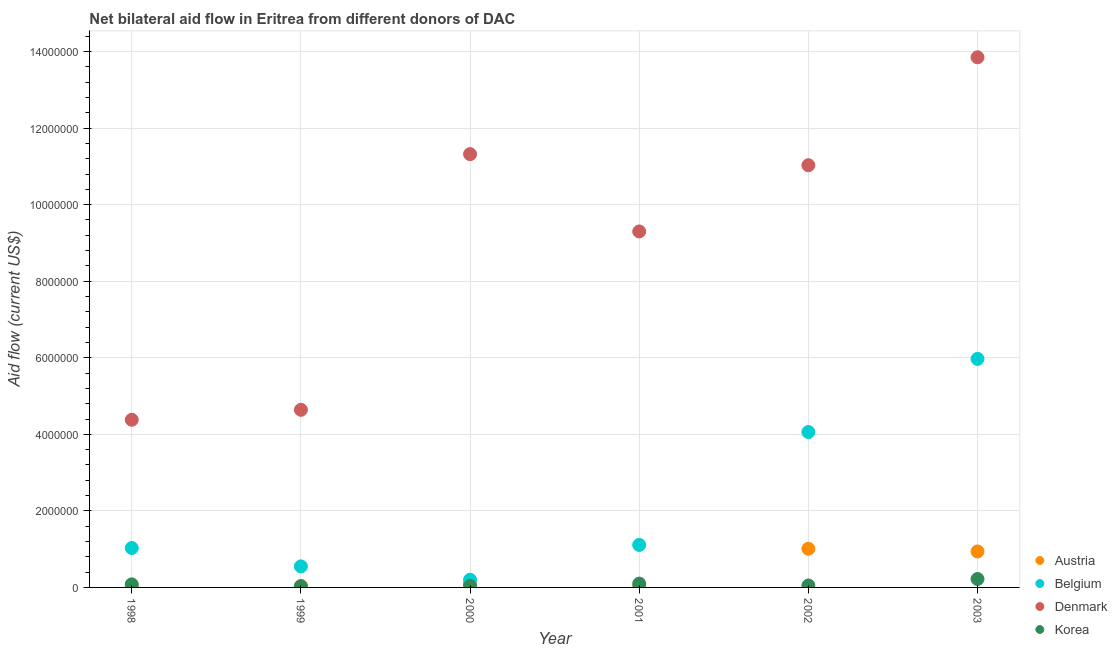What is the amount of aid given by korea in 1998?
Keep it short and to the point. 8.00e+04. Across all years, what is the maximum amount of aid given by denmark?
Ensure brevity in your answer.  1.38e+07. Across all years, what is the minimum amount of aid given by austria?
Ensure brevity in your answer.  2.00e+04. In which year was the amount of aid given by denmark maximum?
Keep it short and to the point. 2003. What is the total amount of aid given by denmark in the graph?
Keep it short and to the point. 5.45e+07. What is the difference between the amount of aid given by korea in 2002 and that in 2003?
Offer a very short reply. -1.70e+05. What is the difference between the amount of aid given by denmark in 2001 and the amount of aid given by austria in 2000?
Ensure brevity in your answer.  9.21e+06. What is the average amount of aid given by denmark per year?
Provide a succinct answer. 9.09e+06. In the year 2001, what is the difference between the amount of aid given by denmark and amount of aid given by austria?
Your answer should be compact. 9.28e+06. In how many years, is the amount of aid given by belgium greater than 2400000 US$?
Your answer should be very brief. 2. What is the ratio of the amount of aid given by denmark in 1999 to that in 2000?
Provide a succinct answer. 0.41. Is the difference between the amount of aid given by austria in 2001 and 2003 greater than the difference between the amount of aid given by denmark in 2001 and 2003?
Ensure brevity in your answer.  Yes. What is the difference between the highest and the second highest amount of aid given by belgium?
Keep it short and to the point. 1.91e+06. What is the difference between the highest and the lowest amount of aid given by austria?
Provide a succinct answer. 9.90e+05. Is the sum of the amount of aid given by austria in 2000 and 2003 greater than the maximum amount of aid given by korea across all years?
Offer a terse response. Yes. Is it the case that in every year, the sum of the amount of aid given by austria and amount of aid given by belgium is greater than the amount of aid given by denmark?
Your answer should be very brief. No. Is the amount of aid given by korea strictly greater than the amount of aid given by belgium over the years?
Give a very brief answer. No. Is the amount of aid given by korea strictly less than the amount of aid given by denmark over the years?
Offer a very short reply. Yes. How many years are there in the graph?
Your response must be concise. 6. What is the difference between two consecutive major ticks on the Y-axis?
Provide a succinct answer. 2.00e+06. Does the graph contain any zero values?
Provide a succinct answer. No. What is the title of the graph?
Your answer should be very brief. Net bilateral aid flow in Eritrea from different donors of DAC. Does "France" appear as one of the legend labels in the graph?
Your response must be concise. No. What is the Aid flow (current US$) of Belgium in 1998?
Give a very brief answer. 1.03e+06. What is the Aid flow (current US$) in Denmark in 1998?
Provide a short and direct response. 4.38e+06. What is the Aid flow (current US$) of Korea in 1998?
Ensure brevity in your answer.  8.00e+04. What is the Aid flow (current US$) of Austria in 1999?
Provide a succinct answer. 4.00e+04. What is the Aid flow (current US$) in Belgium in 1999?
Give a very brief answer. 5.50e+05. What is the Aid flow (current US$) in Denmark in 1999?
Your answer should be compact. 4.64e+06. What is the Aid flow (current US$) in Korea in 1999?
Give a very brief answer. 3.00e+04. What is the Aid flow (current US$) of Austria in 2000?
Ensure brevity in your answer.  9.00e+04. What is the Aid flow (current US$) in Denmark in 2000?
Your answer should be compact. 1.13e+07. What is the Aid flow (current US$) of Belgium in 2001?
Provide a short and direct response. 1.11e+06. What is the Aid flow (current US$) of Denmark in 2001?
Your answer should be very brief. 9.30e+06. What is the Aid flow (current US$) of Austria in 2002?
Provide a succinct answer. 1.01e+06. What is the Aid flow (current US$) in Belgium in 2002?
Offer a terse response. 4.06e+06. What is the Aid flow (current US$) of Denmark in 2002?
Keep it short and to the point. 1.10e+07. What is the Aid flow (current US$) in Korea in 2002?
Give a very brief answer. 5.00e+04. What is the Aid flow (current US$) of Austria in 2003?
Provide a short and direct response. 9.40e+05. What is the Aid flow (current US$) in Belgium in 2003?
Your answer should be very brief. 5.97e+06. What is the Aid flow (current US$) in Denmark in 2003?
Offer a very short reply. 1.38e+07. Across all years, what is the maximum Aid flow (current US$) of Austria?
Offer a very short reply. 1.01e+06. Across all years, what is the maximum Aid flow (current US$) in Belgium?
Ensure brevity in your answer.  5.97e+06. Across all years, what is the maximum Aid flow (current US$) in Denmark?
Provide a succinct answer. 1.38e+07. Across all years, what is the maximum Aid flow (current US$) of Korea?
Your response must be concise. 2.20e+05. Across all years, what is the minimum Aid flow (current US$) of Denmark?
Give a very brief answer. 4.38e+06. What is the total Aid flow (current US$) in Austria in the graph?
Offer a very short reply. 2.12e+06. What is the total Aid flow (current US$) in Belgium in the graph?
Provide a short and direct response. 1.29e+07. What is the total Aid flow (current US$) in Denmark in the graph?
Make the answer very short. 5.45e+07. What is the total Aid flow (current US$) in Korea in the graph?
Your answer should be very brief. 5.20e+05. What is the difference between the Aid flow (current US$) in Austria in 1998 and that in 1999?
Your answer should be very brief. -2.00e+04. What is the difference between the Aid flow (current US$) in Belgium in 1998 and that in 1999?
Provide a short and direct response. 4.80e+05. What is the difference between the Aid flow (current US$) in Korea in 1998 and that in 1999?
Provide a short and direct response. 5.00e+04. What is the difference between the Aid flow (current US$) of Belgium in 1998 and that in 2000?
Provide a succinct answer. 8.30e+05. What is the difference between the Aid flow (current US$) of Denmark in 1998 and that in 2000?
Offer a very short reply. -6.94e+06. What is the difference between the Aid flow (current US$) in Belgium in 1998 and that in 2001?
Your response must be concise. -8.00e+04. What is the difference between the Aid flow (current US$) in Denmark in 1998 and that in 2001?
Give a very brief answer. -4.92e+06. What is the difference between the Aid flow (current US$) in Austria in 1998 and that in 2002?
Provide a short and direct response. -9.90e+05. What is the difference between the Aid flow (current US$) in Belgium in 1998 and that in 2002?
Give a very brief answer. -3.03e+06. What is the difference between the Aid flow (current US$) of Denmark in 1998 and that in 2002?
Your answer should be very brief. -6.65e+06. What is the difference between the Aid flow (current US$) in Austria in 1998 and that in 2003?
Your answer should be very brief. -9.20e+05. What is the difference between the Aid flow (current US$) in Belgium in 1998 and that in 2003?
Your answer should be compact. -4.94e+06. What is the difference between the Aid flow (current US$) in Denmark in 1998 and that in 2003?
Provide a short and direct response. -9.47e+06. What is the difference between the Aid flow (current US$) of Austria in 1999 and that in 2000?
Offer a very short reply. -5.00e+04. What is the difference between the Aid flow (current US$) in Denmark in 1999 and that in 2000?
Provide a succinct answer. -6.68e+06. What is the difference between the Aid flow (current US$) of Austria in 1999 and that in 2001?
Make the answer very short. 2.00e+04. What is the difference between the Aid flow (current US$) of Belgium in 1999 and that in 2001?
Offer a very short reply. -5.60e+05. What is the difference between the Aid flow (current US$) in Denmark in 1999 and that in 2001?
Provide a succinct answer. -4.66e+06. What is the difference between the Aid flow (current US$) in Korea in 1999 and that in 2001?
Provide a succinct answer. -7.00e+04. What is the difference between the Aid flow (current US$) in Austria in 1999 and that in 2002?
Provide a succinct answer. -9.70e+05. What is the difference between the Aid flow (current US$) in Belgium in 1999 and that in 2002?
Keep it short and to the point. -3.51e+06. What is the difference between the Aid flow (current US$) in Denmark in 1999 and that in 2002?
Offer a very short reply. -6.39e+06. What is the difference between the Aid flow (current US$) in Austria in 1999 and that in 2003?
Give a very brief answer. -9.00e+05. What is the difference between the Aid flow (current US$) of Belgium in 1999 and that in 2003?
Make the answer very short. -5.42e+06. What is the difference between the Aid flow (current US$) of Denmark in 1999 and that in 2003?
Your response must be concise. -9.21e+06. What is the difference between the Aid flow (current US$) of Korea in 1999 and that in 2003?
Give a very brief answer. -1.90e+05. What is the difference between the Aid flow (current US$) of Austria in 2000 and that in 2001?
Offer a very short reply. 7.00e+04. What is the difference between the Aid flow (current US$) in Belgium in 2000 and that in 2001?
Your response must be concise. -9.10e+05. What is the difference between the Aid flow (current US$) in Denmark in 2000 and that in 2001?
Your answer should be compact. 2.02e+06. What is the difference between the Aid flow (current US$) in Austria in 2000 and that in 2002?
Make the answer very short. -9.20e+05. What is the difference between the Aid flow (current US$) of Belgium in 2000 and that in 2002?
Your answer should be compact. -3.86e+06. What is the difference between the Aid flow (current US$) of Denmark in 2000 and that in 2002?
Provide a short and direct response. 2.90e+05. What is the difference between the Aid flow (current US$) of Austria in 2000 and that in 2003?
Make the answer very short. -8.50e+05. What is the difference between the Aid flow (current US$) in Belgium in 2000 and that in 2003?
Your response must be concise. -5.77e+06. What is the difference between the Aid flow (current US$) in Denmark in 2000 and that in 2003?
Ensure brevity in your answer.  -2.53e+06. What is the difference between the Aid flow (current US$) in Korea in 2000 and that in 2003?
Provide a short and direct response. -1.80e+05. What is the difference between the Aid flow (current US$) of Austria in 2001 and that in 2002?
Give a very brief answer. -9.90e+05. What is the difference between the Aid flow (current US$) in Belgium in 2001 and that in 2002?
Ensure brevity in your answer.  -2.95e+06. What is the difference between the Aid flow (current US$) of Denmark in 2001 and that in 2002?
Give a very brief answer. -1.73e+06. What is the difference between the Aid flow (current US$) of Austria in 2001 and that in 2003?
Offer a terse response. -9.20e+05. What is the difference between the Aid flow (current US$) in Belgium in 2001 and that in 2003?
Your answer should be compact. -4.86e+06. What is the difference between the Aid flow (current US$) of Denmark in 2001 and that in 2003?
Provide a short and direct response. -4.55e+06. What is the difference between the Aid flow (current US$) of Korea in 2001 and that in 2003?
Make the answer very short. -1.20e+05. What is the difference between the Aid flow (current US$) of Austria in 2002 and that in 2003?
Give a very brief answer. 7.00e+04. What is the difference between the Aid flow (current US$) of Belgium in 2002 and that in 2003?
Offer a very short reply. -1.91e+06. What is the difference between the Aid flow (current US$) in Denmark in 2002 and that in 2003?
Make the answer very short. -2.82e+06. What is the difference between the Aid flow (current US$) of Austria in 1998 and the Aid flow (current US$) of Belgium in 1999?
Give a very brief answer. -5.30e+05. What is the difference between the Aid flow (current US$) of Austria in 1998 and the Aid flow (current US$) of Denmark in 1999?
Give a very brief answer. -4.62e+06. What is the difference between the Aid flow (current US$) of Austria in 1998 and the Aid flow (current US$) of Korea in 1999?
Give a very brief answer. -10000. What is the difference between the Aid flow (current US$) in Belgium in 1998 and the Aid flow (current US$) in Denmark in 1999?
Make the answer very short. -3.61e+06. What is the difference between the Aid flow (current US$) in Denmark in 1998 and the Aid flow (current US$) in Korea in 1999?
Offer a very short reply. 4.35e+06. What is the difference between the Aid flow (current US$) in Austria in 1998 and the Aid flow (current US$) in Belgium in 2000?
Provide a succinct answer. -1.80e+05. What is the difference between the Aid flow (current US$) in Austria in 1998 and the Aid flow (current US$) in Denmark in 2000?
Offer a terse response. -1.13e+07. What is the difference between the Aid flow (current US$) in Belgium in 1998 and the Aid flow (current US$) in Denmark in 2000?
Ensure brevity in your answer.  -1.03e+07. What is the difference between the Aid flow (current US$) in Belgium in 1998 and the Aid flow (current US$) in Korea in 2000?
Your answer should be compact. 9.90e+05. What is the difference between the Aid flow (current US$) of Denmark in 1998 and the Aid flow (current US$) of Korea in 2000?
Ensure brevity in your answer.  4.34e+06. What is the difference between the Aid flow (current US$) of Austria in 1998 and the Aid flow (current US$) of Belgium in 2001?
Make the answer very short. -1.09e+06. What is the difference between the Aid flow (current US$) in Austria in 1998 and the Aid flow (current US$) in Denmark in 2001?
Give a very brief answer. -9.28e+06. What is the difference between the Aid flow (current US$) of Austria in 1998 and the Aid flow (current US$) of Korea in 2001?
Provide a short and direct response. -8.00e+04. What is the difference between the Aid flow (current US$) in Belgium in 1998 and the Aid flow (current US$) in Denmark in 2001?
Keep it short and to the point. -8.27e+06. What is the difference between the Aid flow (current US$) in Belgium in 1998 and the Aid flow (current US$) in Korea in 2001?
Offer a very short reply. 9.30e+05. What is the difference between the Aid flow (current US$) of Denmark in 1998 and the Aid flow (current US$) of Korea in 2001?
Your answer should be compact. 4.28e+06. What is the difference between the Aid flow (current US$) in Austria in 1998 and the Aid flow (current US$) in Belgium in 2002?
Offer a very short reply. -4.04e+06. What is the difference between the Aid flow (current US$) of Austria in 1998 and the Aid flow (current US$) of Denmark in 2002?
Provide a short and direct response. -1.10e+07. What is the difference between the Aid flow (current US$) in Belgium in 1998 and the Aid flow (current US$) in Denmark in 2002?
Your answer should be very brief. -1.00e+07. What is the difference between the Aid flow (current US$) in Belgium in 1998 and the Aid flow (current US$) in Korea in 2002?
Offer a terse response. 9.80e+05. What is the difference between the Aid flow (current US$) of Denmark in 1998 and the Aid flow (current US$) of Korea in 2002?
Ensure brevity in your answer.  4.33e+06. What is the difference between the Aid flow (current US$) in Austria in 1998 and the Aid flow (current US$) in Belgium in 2003?
Your answer should be compact. -5.95e+06. What is the difference between the Aid flow (current US$) of Austria in 1998 and the Aid flow (current US$) of Denmark in 2003?
Provide a short and direct response. -1.38e+07. What is the difference between the Aid flow (current US$) in Belgium in 1998 and the Aid flow (current US$) in Denmark in 2003?
Your answer should be compact. -1.28e+07. What is the difference between the Aid flow (current US$) of Belgium in 1998 and the Aid flow (current US$) of Korea in 2003?
Keep it short and to the point. 8.10e+05. What is the difference between the Aid flow (current US$) in Denmark in 1998 and the Aid flow (current US$) in Korea in 2003?
Give a very brief answer. 4.16e+06. What is the difference between the Aid flow (current US$) of Austria in 1999 and the Aid flow (current US$) of Denmark in 2000?
Offer a very short reply. -1.13e+07. What is the difference between the Aid flow (current US$) in Belgium in 1999 and the Aid flow (current US$) in Denmark in 2000?
Keep it short and to the point. -1.08e+07. What is the difference between the Aid flow (current US$) of Belgium in 1999 and the Aid flow (current US$) of Korea in 2000?
Your answer should be compact. 5.10e+05. What is the difference between the Aid flow (current US$) in Denmark in 1999 and the Aid flow (current US$) in Korea in 2000?
Offer a terse response. 4.60e+06. What is the difference between the Aid flow (current US$) of Austria in 1999 and the Aid flow (current US$) of Belgium in 2001?
Keep it short and to the point. -1.07e+06. What is the difference between the Aid flow (current US$) of Austria in 1999 and the Aid flow (current US$) of Denmark in 2001?
Offer a very short reply. -9.26e+06. What is the difference between the Aid flow (current US$) in Belgium in 1999 and the Aid flow (current US$) in Denmark in 2001?
Give a very brief answer. -8.75e+06. What is the difference between the Aid flow (current US$) of Belgium in 1999 and the Aid flow (current US$) of Korea in 2001?
Your answer should be compact. 4.50e+05. What is the difference between the Aid flow (current US$) of Denmark in 1999 and the Aid flow (current US$) of Korea in 2001?
Your response must be concise. 4.54e+06. What is the difference between the Aid flow (current US$) in Austria in 1999 and the Aid flow (current US$) in Belgium in 2002?
Your answer should be compact. -4.02e+06. What is the difference between the Aid flow (current US$) of Austria in 1999 and the Aid flow (current US$) of Denmark in 2002?
Ensure brevity in your answer.  -1.10e+07. What is the difference between the Aid flow (current US$) of Belgium in 1999 and the Aid flow (current US$) of Denmark in 2002?
Your answer should be compact. -1.05e+07. What is the difference between the Aid flow (current US$) of Belgium in 1999 and the Aid flow (current US$) of Korea in 2002?
Your answer should be compact. 5.00e+05. What is the difference between the Aid flow (current US$) in Denmark in 1999 and the Aid flow (current US$) in Korea in 2002?
Offer a very short reply. 4.59e+06. What is the difference between the Aid flow (current US$) of Austria in 1999 and the Aid flow (current US$) of Belgium in 2003?
Ensure brevity in your answer.  -5.93e+06. What is the difference between the Aid flow (current US$) in Austria in 1999 and the Aid flow (current US$) in Denmark in 2003?
Your answer should be very brief. -1.38e+07. What is the difference between the Aid flow (current US$) in Austria in 1999 and the Aid flow (current US$) in Korea in 2003?
Keep it short and to the point. -1.80e+05. What is the difference between the Aid flow (current US$) of Belgium in 1999 and the Aid flow (current US$) of Denmark in 2003?
Your answer should be compact. -1.33e+07. What is the difference between the Aid flow (current US$) of Belgium in 1999 and the Aid flow (current US$) of Korea in 2003?
Keep it short and to the point. 3.30e+05. What is the difference between the Aid flow (current US$) in Denmark in 1999 and the Aid flow (current US$) in Korea in 2003?
Keep it short and to the point. 4.42e+06. What is the difference between the Aid flow (current US$) in Austria in 2000 and the Aid flow (current US$) in Belgium in 2001?
Make the answer very short. -1.02e+06. What is the difference between the Aid flow (current US$) of Austria in 2000 and the Aid flow (current US$) of Denmark in 2001?
Provide a short and direct response. -9.21e+06. What is the difference between the Aid flow (current US$) of Austria in 2000 and the Aid flow (current US$) of Korea in 2001?
Your answer should be compact. -10000. What is the difference between the Aid flow (current US$) of Belgium in 2000 and the Aid flow (current US$) of Denmark in 2001?
Your answer should be compact. -9.10e+06. What is the difference between the Aid flow (current US$) in Denmark in 2000 and the Aid flow (current US$) in Korea in 2001?
Give a very brief answer. 1.12e+07. What is the difference between the Aid flow (current US$) in Austria in 2000 and the Aid flow (current US$) in Belgium in 2002?
Keep it short and to the point. -3.97e+06. What is the difference between the Aid flow (current US$) in Austria in 2000 and the Aid flow (current US$) in Denmark in 2002?
Ensure brevity in your answer.  -1.09e+07. What is the difference between the Aid flow (current US$) of Austria in 2000 and the Aid flow (current US$) of Korea in 2002?
Provide a short and direct response. 4.00e+04. What is the difference between the Aid flow (current US$) of Belgium in 2000 and the Aid flow (current US$) of Denmark in 2002?
Offer a terse response. -1.08e+07. What is the difference between the Aid flow (current US$) in Belgium in 2000 and the Aid flow (current US$) in Korea in 2002?
Give a very brief answer. 1.50e+05. What is the difference between the Aid flow (current US$) in Denmark in 2000 and the Aid flow (current US$) in Korea in 2002?
Ensure brevity in your answer.  1.13e+07. What is the difference between the Aid flow (current US$) of Austria in 2000 and the Aid flow (current US$) of Belgium in 2003?
Your answer should be compact. -5.88e+06. What is the difference between the Aid flow (current US$) of Austria in 2000 and the Aid flow (current US$) of Denmark in 2003?
Provide a short and direct response. -1.38e+07. What is the difference between the Aid flow (current US$) of Belgium in 2000 and the Aid flow (current US$) of Denmark in 2003?
Ensure brevity in your answer.  -1.36e+07. What is the difference between the Aid flow (current US$) in Belgium in 2000 and the Aid flow (current US$) in Korea in 2003?
Offer a terse response. -2.00e+04. What is the difference between the Aid flow (current US$) in Denmark in 2000 and the Aid flow (current US$) in Korea in 2003?
Make the answer very short. 1.11e+07. What is the difference between the Aid flow (current US$) in Austria in 2001 and the Aid flow (current US$) in Belgium in 2002?
Provide a short and direct response. -4.04e+06. What is the difference between the Aid flow (current US$) of Austria in 2001 and the Aid flow (current US$) of Denmark in 2002?
Give a very brief answer. -1.10e+07. What is the difference between the Aid flow (current US$) in Austria in 2001 and the Aid flow (current US$) in Korea in 2002?
Your answer should be compact. -3.00e+04. What is the difference between the Aid flow (current US$) in Belgium in 2001 and the Aid flow (current US$) in Denmark in 2002?
Provide a short and direct response. -9.92e+06. What is the difference between the Aid flow (current US$) in Belgium in 2001 and the Aid flow (current US$) in Korea in 2002?
Offer a terse response. 1.06e+06. What is the difference between the Aid flow (current US$) in Denmark in 2001 and the Aid flow (current US$) in Korea in 2002?
Provide a short and direct response. 9.25e+06. What is the difference between the Aid flow (current US$) in Austria in 2001 and the Aid flow (current US$) in Belgium in 2003?
Ensure brevity in your answer.  -5.95e+06. What is the difference between the Aid flow (current US$) in Austria in 2001 and the Aid flow (current US$) in Denmark in 2003?
Make the answer very short. -1.38e+07. What is the difference between the Aid flow (current US$) of Belgium in 2001 and the Aid flow (current US$) of Denmark in 2003?
Your answer should be compact. -1.27e+07. What is the difference between the Aid flow (current US$) of Belgium in 2001 and the Aid flow (current US$) of Korea in 2003?
Ensure brevity in your answer.  8.90e+05. What is the difference between the Aid flow (current US$) of Denmark in 2001 and the Aid flow (current US$) of Korea in 2003?
Your answer should be very brief. 9.08e+06. What is the difference between the Aid flow (current US$) of Austria in 2002 and the Aid flow (current US$) of Belgium in 2003?
Your answer should be very brief. -4.96e+06. What is the difference between the Aid flow (current US$) in Austria in 2002 and the Aid flow (current US$) in Denmark in 2003?
Provide a short and direct response. -1.28e+07. What is the difference between the Aid flow (current US$) of Austria in 2002 and the Aid flow (current US$) of Korea in 2003?
Your answer should be very brief. 7.90e+05. What is the difference between the Aid flow (current US$) in Belgium in 2002 and the Aid flow (current US$) in Denmark in 2003?
Your response must be concise. -9.79e+06. What is the difference between the Aid flow (current US$) in Belgium in 2002 and the Aid flow (current US$) in Korea in 2003?
Give a very brief answer. 3.84e+06. What is the difference between the Aid flow (current US$) of Denmark in 2002 and the Aid flow (current US$) of Korea in 2003?
Offer a very short reply. 1.08e+07. What is the average Aid flow (current US$) of Austria per year?
Offer a very short reply. 3.53e+05. What is the average Aid flow (current US$) of Belgium per year?
Ensure brevity in your answer.  2.15e+06. What is the average Aid flow (current US$) in Denmark per year?
Make the answer very short. 9.09e+06. What is the average Aid flow (current US$) in Korea per year?
Your answer should be very brief. 8.67e+04. In the year 1998, what is the difference between the Aid flow (current US$) in Austria and Aid flow (current US$) in Belgium?
Your response must be concise. -1.01e+06. In the year 1998, what is the difference between the Aid flow (current US$) of Austria and Aid flow (current US$) of Denmark?
Provide a succinct answer. -4.36e+06. In the year 1998, what is the difference between the Aid flow (current US$) in Belgium and Aid flow (current US$) in Denmark?
Give a very brief answer. -3.35e+06. In the year 1998, what is the difference between the Aid flow (current US$) of Belgium and Aid flow (current US$) of Korea?
Give a very brief answer. 9.50e+05. In the year 1998, what is the difference between the Aid flow (current US$) of Denmark and Aid flow (current US$) of Korea?
Offer a very short reply. 4.30e+06. In the year 1999, what is the difference between the Aid flow (current US$) of Austria and Aid flow (current US$) of Belgium?
Make the answer very short. -5.10e+05. In the year 1999, what is the difference between the Aid flow (current US$) of Austria and Aid flow (current US$) of Denmark?
Provide a succinct answer. -4.60e+06. In the year 1999, what is the difference between the Aid flow (current US$) of Austria and Aid flow (current US$) of Korea?
Make the answer very short. 10000. In the year 1999, what is the difference between the Aid flow (current US$) in Belgium and Aid flow (current US$) in Denmark?
Ensure brevity in your answer.  -4.09e+06. In the year 1999, what is the difference between the Aid flow (current US$) of Belgium and Aid flow (current US$) of Korea?
Provide a short and direct response. 5.20e+05. In the year 1999, what is the difference between the Aid flow (current US$) in Denmark and Aid flow (current US$) in Korea?
Provide a short and direct response. 4.61e+06. In the year 2000, what is the difference between the Aid flow (current US$) in Austria and Aid flow (current US$) in Denmark?
Your answer should be compact. -1.12e+07. In the year 2000, what is the difference between the Aid flow (current US$) in Belgium and Aid flow (current US$) in Denmark?
Your response must be concise. -1.11e+07. In the year 2000, what is the difference between the Aid flow (current US$) in Belgium and Aid flow (current US$) in Korea?
Your answer should be compact. 1.60e+05. In the year 2000, what is the difference between the Aid flow (current US$) of Denmark and Aid flow (current US$) of Korea?
Your answer should be very brief. 1.13e+07. In the year 2001, what is the difference between the Aid flow (current US$) of Austria and Aid flow (current US$) of Belgium?
Your answer should be compact. -1.09e+06. In the year 2001, what is the difference between the Aid flow (current US$) of Austria and Aid flow (current US$) of Denmark?
Ensure brevity in your answer.  -9.28e+06. In the year 2001, what is the difference between the Aid flow (current US$) of Belgium and Aid flow (current US$) of Denmark?
Offer a terse response. -8.19e+06. In the year 2001, what is the difference between the Aid flow (current US$) of Belgium and Aid flow (current US$) of Korea?
Provide a succinct answer. 1.01e+06. In the year 2001, what is the difference between the Aid flow (current US$) in Denmark and Aid flow (current US$) in Korea?
Your answer should be compact. 9.20e+06. In the year 2002, what is the difference between the Aid flow (current US$) of Austria and Aid flow (current US$) of Belgium?
Make the answer very short. -3.05e+06. In the year 2002, what is the difference between the Aid flow (current US$) of Austria and Aid flow (current US$) of Denmark?
Your answer should be compact. -1.00e+07. In the year 2002, what is the difference between the Aid flow (current US$) in Austria and Aid flow (current US$) in Korea?
Provide a succinct answer. 9.60e+05. In the year 2002, what is the difference between the Aid flow (current US$) of Belgium and Aid flow (current US$) of Denmark?
Offer a very short reply. -6.97e+06. In the year 2002, what is the difference between the Aid flow (current US$) in Belgium and Aid flow (current US$) in Korea?
Make the answer very short. 4.01e+06. In the year 2002, what is the difference between the Aid flow (current US$) in Denmark and Aid flow (current US$) in Korea?
Your answer should be very brief. 1.10e+07. In the year 2003, what is the difference between the Aid flow (current US$) of Austria and Aid flow (current US$) of Belgium?
Provide a short and direct response. -5.03e+06. In the year 2003, what is the difference between the Aid flow (current US$) in Austria and Aid flow (current US$) in Denmark?
Make the answer very short. -1.29e+07. In the year 2003, what is the difference between the Aid flow (current US$) of Austria and Aid flow (current US$) of Korea?
Make the answer very short. 7.20e+05. In the year 2003, what is the difference between the Aid flow (current US$) of Belgium and Aid flow (current US$) of Denmark?
Offer a very short reply. -7.88e+06. In the year 2003, what is the difference between the Aid flow (current US$) of Belgium and Aid flow (current US$) of Korea?
Provide a short and direct response. 5.75e+06. In the year 2003, what is the difference between the Aid flow (current US$) in Denmark and Aid flow (current US$) in Korea?
Keep it short and to the point. 1.36e+07. What is the ratio of the Aid flow (current US$) of Belgium in 1998 to that in 1999?
Provide a short and direct response. 1.87. What is the ratio of the Aid flow (current US$) in Denmark in 1998 to that in 1999?
Provide a succinct answer. 0.94. What is the ratio of the Aid flow (current US$) in Korea in 1998 to that in 1999?
Provide a short and direct response. 2.67. What is the ratio of the Aid flow (current US$) in Austria in 1998 to that in 2000?
Ensure brevity in your answer.  0.22. What is the ratio of the Aid flow (current US$) of Belgium in 1998 to that in 2000?
Provide a short and direct response. 5.15. What is the ratio of the Aid flow (current US$) in Denmark in 1998 to that in 2000?
Provide a succinct answer. 0.39. What is the ratio of the Aid flow (current US$) of Belgium in 1998 to that in 2001?
Ensure brevity in your answer.  0.93. What is the ratio of the Aid flow (current US$) of Denmark in 1998 to that in 2001?
Your answer should be compact. 0.47. What is the ratio of the Aid flow (current US$) in Austria in 1998 to that in 2002?
Provide a short and direct response. 0.02. What is the ratio of the Aid flow (current US$) of Belgium in 1998 to that in 2002?
Provide a succinct answer. 0.25. What is the ratio of the Aid flow (current US$) of Denmark in 1998 to that in 2002?
Give a very brief answer. 0.4. What is the ratio of the Aid flow (current US$) of Korea in 1998 to that in 2002?
Offer a terse response. 1.6. What is the ratio of the Aid flow (current US$) of Austria in 1998 to that in 2003?
Provide a short and direct response. 0.02. What is the ratio of the Aid flow (current US$) of Belgium in 1998 to that in 2003?
Your answer should be compact. 0.17. What is the ratio of the Aid flow (current US$) of Denmark in 1998 to that in 2003?
Offer a very short reply. 0.32. What is the ratio of the Aid flow (current US$) in Korea in 1998 to that in 2003?
Ensure brevity in your answer.  0.36. What is the ratio of the Aid flow (current US$) of Austria in 1999 to that in 2000?
Offer a very short reply. 0.44. What is the ratio of the Aid flow (current US$) of Belgium in 1999 to that in 2000?
Keep it short and to the point. 2.75. What is the ratio of the Aid flow (current US$) in Denmark in 1999 to that in 2000?
Ensure brevity in your answer.  0.41. What is the ratio of the Aid flow (current US$) of Korea in 1999 to that in 2000?
Ensure brevity in your answer.  0.75. What is the ratio of the Aid flow (current US$) of Austria in 1999 to that in 2001?
Your answer should be compact. 2. What is the ratio of the Aid flow (current US$) in Belgium in 1999 to that in 2001?
Make the answer very short. 0.5. What is the ratio of the Aid flow (current US$) in Denmark in 1999 to that in 2001?
Offer a terse response. 0.5. What is the ratio of the Aid flow (current US$) in Korea in 1999 to that in 2001?
Your answer should be compact. 0.3. What is the ratio of the Aid flow (current US$) of Austria in 1999 to that in 2002?
Your response must be concise. 0.04. What is the ratio of the Aid flow (current US$) of Belgium in 1999 to that in 2002?
Offer a very short reply. 0.14. What is the ratio of the Aid flow (current US$) in Denmark in 1999 to that in 2002?
Keep it short and to the point. 0.42. What is the ratio of the Aid flow (current US$) in Austria in 1999 to that in 2003?
Ensure brevity in your answer.  0.04. What is the ratio of the Aid flow (current US$) in Belgium in 1999 to that in 2003?
Provide a short and direct response. 0.09. What is the ratio of the Aid flow (current US$) in Denmark in 1999 to that in 2003?
Make the answer very short. 0.34. What is the ratio of the Aid flow (current US$) of Korea in 1999 to that in 2003?
Your response must be concise. 0.14. What is the ratio of the Aid flow (current US$) in Belgium in 2000 to that in 2001?
Provide a succinct answer. 0.18. What is the ratio of the Aid flow (current US$) of Denmark in 2000 to that in 2001?
Offer a very short reply. 1.22. What is the ratio of the Aid flow (current US$) of Austria in 2000 to that in 2002?
Ensure brevity in your answer.  0.09. What is the ratio of the Aid flow (current US$) of Belgium in 2000 to that in 2002?
Provide a succinct answer. 0.05. What is the ratio of the Aid flow (current US$) in Denmark in 2000 to that in 2002?
Keep it short and to the point. 1.03. What is the ratio of the Aid flow (current US$) of Austria in 2000 to that in 2003?
Offer a terse response. 0.1. What is the ratio of the Aid flow (current US$) of Belgium in 2000 to that in 2003?
Give a very brief answer. 0.03. What is the ratio of the Aid flow (current US$) in Denmark in 2000 to that in 2003?
Provide a succinct answer. 0.82. What is the ratio of the Aid flow (current US$) in Korea in 2000 to that in 2003?
Ensure brevity in your answer.  0.18. What is the ratio of the Aid flow (current US$) in Austria in 2001 to that in 2002?
Your answer should be very brief. 0.02. What is the ratio of the Aid flow (current US$) of Belgium in 2001 to that in 2002?
Your answer should be compact. 0.27. What is the ratio of the Aid flow (current US$) of Denmark in 2001 to that in 2002?
Provide a succinct answer. 0.84. What is the ratio of the Aid flow (current US$) of Korea in 2001 to that in 2002?
Your response must be concise. 2. What is the ratio of the Aid flow (current US$) in Austria in 2001 to that in 2003?
Give a very brief answer. 0.02. What is the ratio of the Aid flow (current US$) of Belgium in 2001 to that in 2003?
Ensure brevity in your answer.  0.19. What is the ratio of the Aid flow (current US$) of Denmark in 2001 to that in 2003?
Your answer should be compact. 0.67. What is the ratio of the Aid flow (current US$) of Korea in 2001 to that in 2003?
Give a very brief answer. 0.45. What is the ratio of the Aid flow (current US$) of Austria in 2002 to that in 2003?
Offer a very short reply. 1.07. What is the ratio of the Aid flow (current US$) of Belgium in 2002 to that in 2003?
Provide a short and direct response. 0.68. What is the ratio of the Aid flow (current US$) of Denmark in 2002 to that in 2003?
Give a very brief answer. 0.8. What is the ratio of the Aid flow (current US$) of Korea in 2002 to that in 2003?
Ensure brevity in your answer.  0.23. What is the difference between the highest and the second highest Aid flow (current US$) of Austria?
Make the answer very short. 7.00e+04. What is the difference between the highest and the second highest Aid flow (current US$) in Belgium?
Your response must be concise. 1.91e+06. What is the difference between the highest and the second highest Aid flow (current US$) in Denmark?
Your response must be concise. 2.53e+06. What is the difference between the highest and the second highest Aid flow (current US$) in Korea?
Ensure brevity in your answer.  1.20e+05. What is the difference between the highest and the lowest Aid flow (current US$) of Austria?
Your answer should be compact. 9.90e+05. What is the difference between the highest and the lowest Aid flow (current US$) in Belgium?
Provide a short and direct response. 5.77e+06. What is the difference between the highest and the lowest Aid flow (current US$) of Denmark?
Keep it short and to the point. 9.47e+06. What is the difference between the highest and the lowest Aid flow (current US$) of Korea?
Offer a very short reply. 1.90e+05. 